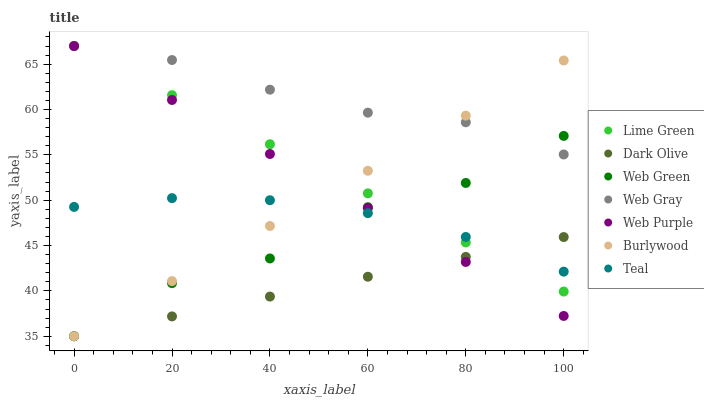Does Dark Olive have the minimum area under the curve?
Answer yes or no. Yes. Does Web Gray have the maximum area under the curve?
Answer yes or no. Yes. Does Burlywood have the minimum area under the curve?
Answer yes or no. No. Does Burlywood have the maximum area under the curve?
Answer yes or no. No. Is Web Purple the smoothest?
Answer yes or no. Yes. Is Web Green the roughest?
Answer yes or no. Yes. Is Burlywood the smoothest?
Answer yes or no. No. Is Burlywood the roughest?
Answer yes or no. No. Does Burlywood have the lowest value?
Answer yes or no. Yes. Does Web Purple have the lowest value?
Answer yes or no. No. Does Lime Green have the highest value?
Answer yes or no. Yes. Does Burlywood have the highest value?
Answer yes or no. No. Is Teal less than Web Gray?
Answer yes or no. Yes. Is Web Gray greater than Dark Olive?
Answer yes or no. Yes. Does Web Purple intersect Dark Olive?
Answer yes or no. Yes. Is Web Purple less than Dark Olive?
Answer yes or no. No. Is Web Purple greater than Dark Olive?
Answer yes or no. No. Does Teal intersect Web Gray?
Answer yes or no. No. 